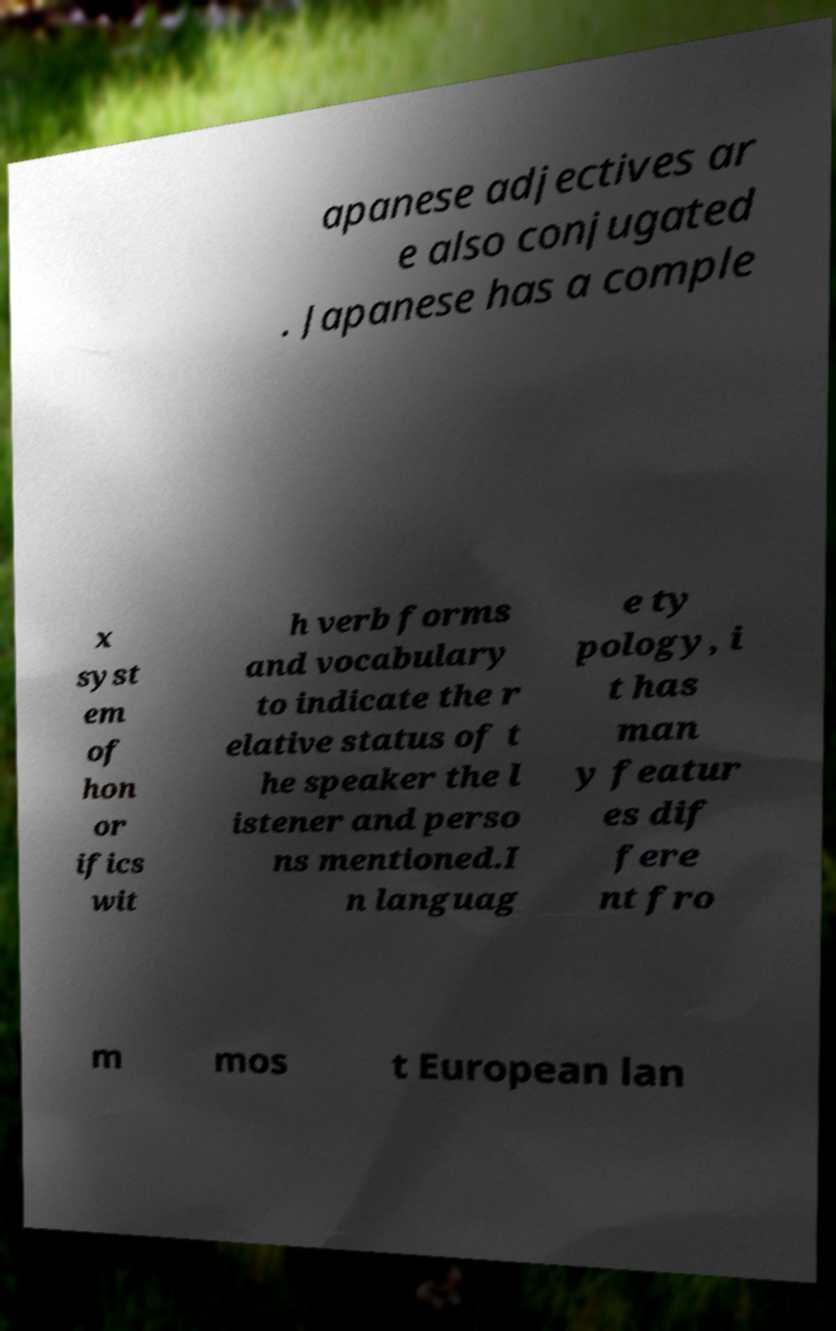Could you assist in decoding the text presented in this image and type it out clearly? apanese adjectives ar e also conjugated . Japanese has a comple x syst em of hon or ifics wit h verb forms and vocabulary to indicate the r elative status of t he speaker the l istener and perso ns mentioned.I n languag e ty pology, i t has man y featur es dif fere nt fro m mos t European lan 